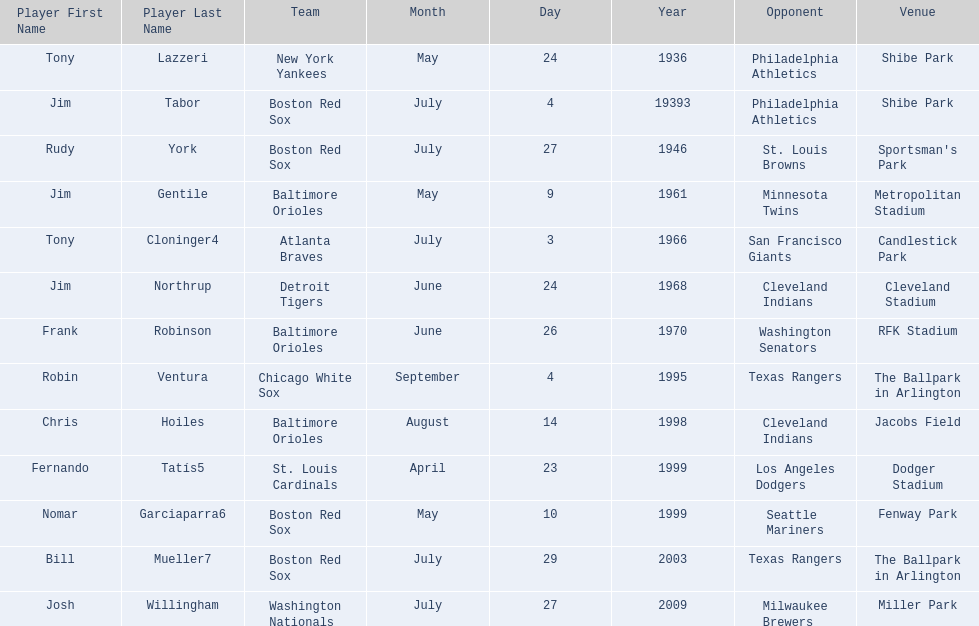Who were all the teams? New York Yankees, Boston Red Sox, Boston Red Sox, Baltimore Orioles, Atlanta Braves, Detroit Tigers, Baltimore Orioles, Chicago White Sox, Baltimore Orioles, St. Louis Cardinals, Boston Red Sox, Boston Red Sox, Washington Nationals. What about opponents? Philadelphia Athletics, Philadelphia Athletics, St. Louis Browns, Minnesota Twins, San Francisco Giants, Cleveland Indians, Washington Senators, Texas Rangers, Cleveland Indians, Los Angeles Dodgers, Seattle Mariners, Texas Rangers, Milwaukee Brewers. And when did they play? May 24, 1936, July 4, 19393, July 27, 1946, May 9, 1961, July 3, 1966, June 24, 1968, June 26, 1970, September 4, 1995, August 14, 1998, April 23, 1999, May 10, 1999, July 29, 2003, July 27, 2009. Which team played the red sox on july 27, 1946	? St. Louis Browns. 